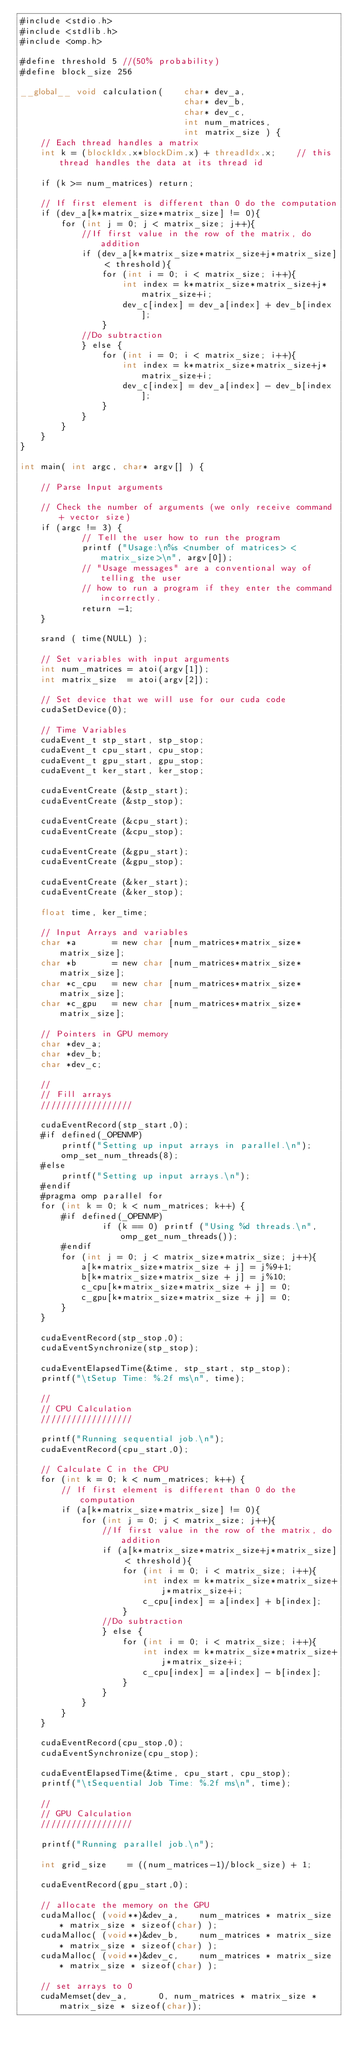Convert code to text. <code><loc_0><loc_0><loc_500><loc_500><_Cuda_>#include <stdio.h>
#include <stdlib.h>
#include <omp.h>

#define threshold 5 //(50% probability)
#define block_size 256

__global__ void calculation(    char* dev_a, 
                                char* dev_b, 
                                char* dev_c,
                                int num_matrices,                                                
                                int matrix_size ) {
    // Each thread handles a matrix
    int k = (blockIdx.x*blockDim.x) + threadIdx.x;    // this thread handles the data at its thread id

    if (k >= num_matrices) return;
    
    // If first element is different than 0 do the computation
    if (dev_a[k*matrix_size*matrix_size] != 0){
        for (int j = 0; j < matrix_size; j++){
            //If first value in the row of the matrix, do addition
            if (dev_a[k*matrix_size*matrix_size+j*matrix_size] < threshold){
                for (int i = 0; i < matrix_size; i++){
                    int index = k*matrix_size*matrix_size+j*matrix_size+i;
                    dev_c[index] = dev_a[index] + dev_b[index];
                }
            //Do subtraction
            } else {
                for (int i = 0; i < matrix_size; i++){
                    int index = k*matrix_size*matrix_size+j*matrix_size+i;
                    dev_c[index] = dev_a[index] - dev_b[index];
                }
            }
        }
    }
}

int main( int argc, char* argv[] ) { 

    // Parse Input arguments
    
    // Check the number of arguments (we only receive command + vector size)
    if (argc != 3) {
            // Tell the user how to run the program
            printf ("Usage:\n%s <number of matrices> <matrix_size>\n", argv[0]);
            // "Usage messages" are a conventional way of telling the user
            // how to run a program if they enter the command incorrectly.
            return -1;
    }
    
    srand ( time(NULL) );

    // Set variables with input arguments
    int num_matrices = atoi(argv[1]);
    int matrix_size  = atoi(argv[2]);
            
    // Set device that we will use for our cuda code
    cudaSetDevice(0);
        
	// Time Variables
    cudaEvent_t stp_start, stp_stop;
    cudaEvent_t cpu_start, cpu_stop;
    cudaEvent_t gpu_start, gpu_stop;
    cudaEvent_t ker_start, ker_stop;

    cudaEventCreate (&stp_start);
    cudaEventCreate (&stp_stop);

    cudaEventCreate (&cpu_start);
    cudaEventCreate (&cpu_stop);

    cudaEventCreate (&gpu_start);
    cudaEventCreate (&gpu_stop);

    cudaEventCreate (&ker_start);
    cudaEventCreate (&ker_stop);
	
	float time, ker_time;
        
    // Input Arrays and variables
    char *a       = new char [num_matrices*matrix_size*matrix_size];
    char *b       = new char [num_matrices*matrix_size*matrix_size];
    char *c_cpu   = new char [num_matrices*matrix_size*matrix_size]; 
    char *c_gpu   = new char [num_matrices*matrix_size*matrix_size];

    // Pointers in GPU memory
    char *dev_a;
    char *dev_b;
    char *dev_c;

    //
    // Fill arrays
    //////////////////
        
	cudaEventRecord(stp_start,0);
    #if defined(_OPENMP)
        printf("Setting up input arrays in parallel.\n");
        omp_set_num_threads(8);
    #else
        printf("Setting up input arrays.\n");
    #endif
    #pragma omp parallel for
    for (int k = 0; k < num_matrices; k++) {
        #if defined(_OPENMP)                
                if (k == 0) printf ("Using %d threads.\n", omp_get_num_threads());
        #endif
        for (int j = 0; j < matrix_size*matrix_size; j++){
            a[k*matrix_size*matrix_size + j] = j%9+1;
            b[k*matrix_size*matrix_size + j] = j%10;
            c_cpu[k*matrix_size*matrix_size + j] = 0;
            c_gpu[k*matrix_size*matrix_size + j] = 0;
        }   
    }
        
	cudaEventRecord(stp_stop,0);
	cudaEventSynchronize(stp_stop);
        
	cudaEventElapsedTime(&time, stp_start, stp_stop);
	printf("\tSetup Time: %.2f ms\n", time);

    //
    // CPU Calculation
    //////////////////
    
    printf("Running sequential job.\n");
    cudaEventRecord(cpu_start,0);

    // Calculate C in the CPU
    for (int k = 0; k < num_matrices; k++) {
        // If first element is different than 0 do the computation
        if (a[k*matrix_size*matrix_size] != 0){
            for (int j = 0; j < matrix_size; j++){
                //If first value in the row of the matrix, do addition
                if (a[k*matrix_size*matrix_size+j*matrix_size] < threshold){
                    for (int i = 0; i < matrix_size; i++){
                        int index = k*matrix_size*matrix_size+j*matrix_size+i;
                        c_cpu[index] = a[index] + b[index];
                    }
                //Do subtraction
                } else {
                    for (int i = 0; i < matrix_size; i++){
                        int index = k*matrix_size*matrix_size+j*matrix_size+i;
                        c_cpu[index] = a[index] - b[index];
                    }
                }
            }                        
        }
    }
        
	cudaEventRecord(cpu_stop,0);
	cudaEventSynchronize(cpu_stop);
        
	cudaEventElapsedTime(&time, cpu_start, cpu_stop);
	printf("\tSequential Job Time: %.2f ms\n", time);
      
    //
    // GPU Calculation
    //////////////////
    
    printf("Running parallel job.\n");
    
    int grid_size    = ((num_matrices-1)/block_size) + 1;

    cudaEventRecord(gpu_start,0);
    
    // allocate the memory on the GPU
    cudaMalloc( (void**)&dev_a,    num_matrices * matrix_size * matrix_size * sizeof(char) );
    cudaMalloc( (void**)&dev_b,    num_matrices * matrix_size * matrix_size * sizeof(char) );
    cudaMalloc( (void**)&dev_c,    num_matrices * matrix_size * matrix_size * sizeof(char) );

    // set arrays to 0
    cudaMemset(dev_a,      0, num_matrices * matrix_size * matrix_size * sizeof(char));</code> 